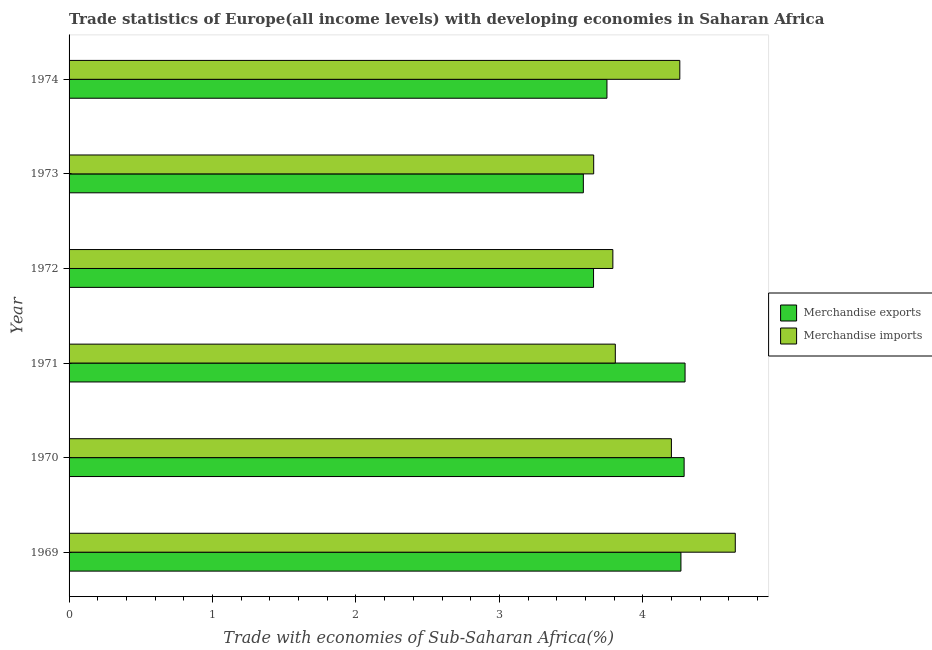Are the number of bars per tick equal to the number of legend labels?
Your answer should be very brief. Yes. How many bars are there on the 3rd tick from the top?
Provide a short and direct response. 2. What is the label of the 1st group of bars from the top?
Offer a terse response. 1974. What is the merchandise exports in 1970?
Your answer should be very brief. 4.29. Across all years, what is the maximum merchandise imports?
Keep it short and to the point. 4.64. Across all years, what is the minimum merchandise exports?
Keep it short and to the point. 3.58. In which year was the merchandise exports minimum?
Offer a very short reply. 1973. What is the total merchandise imports in the graph?
Your answer should be very brief. 24.36. What is the difference between the merchandise exports in 1969 and that in 1972?
Your answer should be very brief. 0.61. What is the difference between the merchandise imports in 1972 and the merchandise exports in 1970?
Make the answer very short. -0.5. What is the average merchandise imports per year?
Your response must be concise. 4.06. In the year 1970, what is the difference between the merchandise exports and merchandise imports?
Give a very brief answer. 0.09. In how many years, is the merchandise exports greater than 1.2 %?
Provide a succinct answer. 6. What is the ratio of the merchandise imports in 1970 to that in 1972?
Your answer should be very brief. 1.11. Is the difference between the merchandise exports in 1970 and 1972 greater than the difference between the merchandise imports in 1970 and 1972?
Offer a very short reply. Yes. What is the difference between the highest and the second highest merchandise imports?
Offer a very short reply. 0.39. What is the difference between the highest and the lowest merchandise imports?
Provide a short and direct response. 0.99. Is the sum of the merchandise exports in 1970 and 1972 greater than the maximum merchandise imports across all years?
Make the answer very short. Yes. What does the 2nd bar from the top in 1972 represents?
Keep it short and to the point. Merchandise exports. How many years are there in the graph?
Offer a very short reply. 6. What is the difference between two consecutive major ticks on the X-axis?
Offer a very short reply. 1. Are the values on the major ticks of X-axis written in scientific E-notation?
Provide a short and direct response. No. Does the graph contain any zero values?
Give a very brief answer. No. Does the graph contain grids?
Your answer should be compact. No. How many legend labels are there?
Provide a short and direct response. 2. How are the legend labels stacked?
Provide a short and direct response. Vertical. What is the title of the graph?
Your answer should be compact. Trade statistics of Europe(all income levels) with developing economies in Saharan Africa. Does "Transport services" appear as one of the legend labels in the graph?
Your answer should be compact. No. What is the label or title of the X-axis?
Offer a terse response. Trade with economies of Sub-Saharan Africa(%). What is the Trade with economies of Sub-Saharan Africa(%) of Merchandise exports in 1969?
Ensure brevity in your answer.  4.27. What is the Trade with economies of Sub-Saharan Africa(%) of Merchandise imports in 1969?
Provide a succinct answer. 4.64. What is the Trade with economies of Sub-Saharan Africa(%) in Merchandise exports in 1970?
Keep it short and to the point. 4.29. What is the Trade with economies of Sub-Saharan Africa(%) of Merchandise imports in 1970?
Your answer should be compact. 4.2. What is the Trade with economies of Sub-Saharan Africa(%) in Merchandise exports in 1971?
Make the answer very short. 4.29. What is the Trade with economies of Sub-Saharan Africa(%) of Merchandise imports in 1971?
Offer a very short reply. 3.81. What is the Trade with economies of Sub-Saharan Africa(%) in Merchandise exports in 1972?
Give a very brief answer. 3.66. What is the Trade with economies of Sub-Saharan Africa(%) in Merchandise imports in 1972?
Keep it short and to the point. 3.79. What is the Trade with economies of Sub-Saharan Africa(%) of Merchandise exports in 1973?
Keep it short and to the point. 3.58. What is the Trade with economies of Sub-Saharan Africa(%) in Merchandise imports in 1973?
Offer a terse response. 3.66. What is the Trade with economies of Sub-Saharan Africa(%) in Merchandise exports in 1974?
Give a very brief answer. 3.75. What is the Trade with economies of Sub-Saharan Africa(%) of Merchandise imports in 1974?
Offer a terse response. 4.26. Across all years, what is the maximum Trade with economies of Sub-Saharan Africa(%) in Merchandise exports?
Offer a terse response. 4.29. Across all years, what is the maximum Trade with economies of Sub-Saharan Africa(%) in Merchandise imports?
Your response must be concise. 4.64. Across all years, what is the minimum Trade with economies of Sub-Saharan Africa(%) in Merchandise exports?
Provide a short and direct response. 3.58. Across all years, what is the minimum Trade with economies of Sub-Saharan Africa(%) in Merchandise imports?
Your response must be concise. 3.66. What is the total Trade with economies of Sub-Saharan Africa(%) in Merchandise exports in the graph?
Keep it short and to the point. 23.84. What is the total Trade with economies of Sub-Saharan Africa(%) of Merchandise imports in the graph?
Offer a terse response. 24.36. What is the difference between the Trade with economies of Sub-Saharan Africa(%) of Merchandise exports in 1969 and that in 1970?
Keep it short and to the point. -0.02. What is the difference between the Trade with economies of Sub-Saharan Africa(%) in Merchandise imports in 1969 and that in 1970?
Offer a very short reply. 0.45. What is the difference between the Trade with economies of Sub-Saharan Africa(%) in Merchandise exports in 1969 and that in 1971?
Give a very brief answer. -0.03. What is the difference between the Trade with economies of Sub-Saharan Africa(%) of Merchandise imports in 1969 and that in 1971?
Offer a terse response. 0.84. What is the difference between the Trade with economies of Sub-Saharan Africa(%) of Merchandise exports in 1969 and that in 1972?
Make the answer very short. 0.61. What is the difference between the Trade with economies of Sub-Saharan Africa(%) in Merchandise imports in 1969 and that in 1972?
Offer a very short reply. 0.85. What is the difference between the Trade with economies of Sub-Saharan Africa(%) in Merchandise exports in 1969 and that in 1973?
Keep it short and to the point. 0.68. What is the difference between the Trade with economies of Sub-Saharan Africa(%) of Merchandise imports in 1969 and that in 1973?
Your response must be concise. 0.99. What is the difference between the Trade with economies of Sub-Saharan Africa(%) of Merchandise exports in 1969 and that in 1974?
Your answer should be compact. 0.52. What is the difference between the Trade with economies of Sub-Saharan Africa(%) in Merchandise imports in 1969 and that in 1974?
Your answer should be compact. 0.39. What is the difference between the Trade with economies of Sub-Saharan Africa(%) of Merchandise exports in 1970 and that in 1971?
Offer a very short reply. -0.01. What is the difference between the Trade with economies of Sub-Saharan Africa(%) in Merchandise imports in 1970 and that in 1971?
Your response must be concise. 0.39. What is the difference between the Trade with economies of Sub-Saharan Africa(%) of Merchandise exports in 1970 and that in 1972?
Make the answer very short. 0.63. What is the difference between the Trade with economies of Sub-Saharan Africa(%) of Merchandise imports in 1970 and that in 1972?
Provide a short and direct response. 0.41. What is the difference between the Trade with economies of Sub-Saharan Africa(%) in Merchandise exports in 1970 and that in 1973?
Ensure brevity in your answer.  0.7. What is the difference between the Trade with economies of Sub-Saharan Africa(%) in Merchandise imports in 1970 and that in 1973?
Provide a short and direct response. 0.54. What is the difference between the Trade with economies of Sub-Saharan Africa(%) in Merchandise exports in 1970 and that in 1974?
Your answer should be compact. 0.54. What is the difference between the Trade with economies of Sub-Saharan Africa(%) in Merchandise imports in 1970 and that in 1974?
Make the answer very short. -0.06. What is the difference between the Trade with economies of Sub-Saharan Africa(%) in Merchandise exports in 1971 and that in 1972?
Provide a short and direct response. 0.64. What is the difference between the Trade with economies of Sub-Saharan Africa(%) of Merchandise imports in 1971 and that in 1972?
Keep it short and to the point. 0.02. What is the difference between the Trade with economies of Sub-Saharan Africa(%) of Merchandise exports in 1971 and that in 1973?
Your response must be concise. 0.71. What is the difference between the Trade with economies of Sub-Saharan Africa(%) in Merchandise imports in 1971 and that in 1973?
Your response must be concise. 0.15. What is the difference between the Trade with economies of Sub-Saharan Africa(%) of Merchandise exports in 1971 and that in 1974?
Make the answer very short. 0.54. What is the difference between the Trade with economies of Sub-Saharan Africa(%) of Merchandise imports in 1971 and that in 1974?
Your answer should be very brief. -0.45. What is the difference between the Trade with economies of Sub-Saharan Africa(%) of Merchandise exports in 1972 and that in 1973?
Your response must be concise. 0.07. What is the difference between the Trade with economies of Sub-Saharan Africa(%) of Merchandise imports in 1972 and that in 1973?
Your answer should be very brief. 0.13. What is the difference between the Trade with economies of Sub-Saharan Africa(%) of Merchandise exports in 1972 and that in 1974?
Keep it short and to the point. -0.09. What is the difference between the Trade with economies of Sub-Saharan Africa(%) of Merchandise imports in 1972 and that in 1974?
Make the answer very short. -0.47. What is the difference between the Trade with economies of Sub-Saharan Africa(%) of Merchandise exports in 1973 and that in 1974?
Provide a short and direct response. -0.16. What is the difference between the Trade with economies of Sub-Saharan Africa(%) in Merchandise imports in 1973 and that in 1974?
Make the answer very short. -0.6. What is the difference between the Trade with economies of Sub-Saharan Africa(%) of Merchandise exports in 1969 and the Trade with economies of Sub-Saharan Africa(%) of Merchandise imports in 1970?
Give a very brief answer. 0.07. What is the difference between the Trade with economies of Sub-Saharan Africa(%) in Merchandise exports in 1969 and the Trade with economies of Sub-Saharan Africa(%) in Merchandise imports in 1971?
Make the answer very short. 0.46. What is the difference between the Trade with economies of Sub-Saharan Africa(%) of Merchandise exports in 1969 and the Trade with economies of Sub-Saharan Africa(%) of Merchandise imports in 1972?
Your answer should be compact. 0.47. What is the difference between the Trade with economies of Sub-Saharan Africa(%) of Merchandise exports in 1969 and the Trade with economies of Sub-Saharan Africa(%) of Merchandise imports in 1973?
Offer a terse response. 0.61. What is the difference between the Trade with economies of Sub-Saharan Africa(%) in Merchandise exports in 1969 and the Trade with economies of Sub-Saharan Africa(%) in Merchandise imports in 1974?
Give a very brief answer. 0.01. What is the difference between the Trade with economies of Sub-Saharan Africa(%) in Merchandise exports in 1970 and the Trade with economies of Sub-Saharan Africa(%) in Merchandise imports in 1971?
Provide a succinct answer. 0.48. What is the difference between the Trade with economies of Sub-Saharan Africa(%) of Merchandise exports in 1970 and the Trade with economies of Sub-Saharan Africa(%) of Merchandise imports in 1972?
Ensure brevity in your answer.  0.5. What is the difference between the Trade with economies of Sub-Saharan Africa(%) in Merchandise exports in 1970 and the Trade with economies of Sub-Saharan Africa(%) in Merchandise imports in 1973?
Your response must be concise. 0.63. What is the difference between the Trade with economies of Sub-Saharan Africa(%) in Merchandise exports in 1970 and the Trade with economies of Sub-Saharan Africa(%) in Merchandise imports in 1974?
Your answer should be compact. 0.03. What is the difference between the Trade with economies of Sub-Saharan Africa(%) of Merchandise exports in 1971 and the Trade with economies of Sub-Saharan Africa(%) of Merchandise imports in 1972?
Provide a short and direct response. 0.5. What is the difference between the Trade with economies of Sub-Saharan Africa(%) in Merchandise exports in 1971 and the Trade with economies of Sub-Saharan Africa(%) in Merchandise imports in 1973?
Your response must be concise. 0.64. What is the difference between the Trade with economies of Sub-Saharan Africa(%) in Merchandise exports in 1971 and the Trade with economies of Sub-Saharan Africa(%) in Merchandise imports in 1974?
Provide a succinct answer. 0.04. What is the difference between the Trade with economies of Sub-Saharan Africa(%) of Merchandise exports in 1972 and the Trade with economies of Sub-Saharan Africa(%) of Merchandise imports in 1973?
Give a very brief answer. -0. What is the difference between the Trade with economies of Sub-Saharan Africa(%) in Merchandise exports in 1972 and the Trade with economies of Sub-Saharan Africa(%) in Merchandise imports in 1974?
Your response must be concise. -0.6. What is the difference between the Trade with economies of Sub-Saharan Africa(%) in Merchandise exports in 1973 and the Trade with economies of Sub-Saharan Africa(%) in Merchandise imports in 1974?
Ensure brevity in your answer.  -0.67. What is the average Trade with economies of Sub-Saharan Africa(%) of Merchandise exports per year?
Keep it short and to the point. 3.97. What is the average Trade with economies of Sub-Saharan Africa(%) in Merchandise imports per year?
Give a very brief answer. 4.06. In the year 1969, what is the difference between the Trade with economies of Sub-Saharan Africa(%) in Merchandise exports and Trade with economies of Sub-Saharan Africa(%) in Merchandise imports?
Make the answer very short. -0.38. In the year 1970, what is the difference between the Trade with economies of Sub-Saharan Africa(%) in Merchandise exports and Trade with economies of Sub-Saharan Africa(%) in Merchandise imports?
Ensure brevity in your answer.  0.09. In the year 1971, what is the difference between the Trade with economies of Sub-Saharan Africa(%) in Merchandise exports and Trade with economies of Sub-Saharan Africa(%) in Merchandise imports?
Offer a terse response. 0.49. In the year 1972, what is the difference between the Trade with economies of Sub-Saharan Africa(%) in Merchandise exports and Trade with economies of Sub-Saharan Africa(%) in Merchandise imports?
Offer a very short reply. -0.13. In the year 1973, what is the difference between the Trade with economies of Sub-Saharan Africa(%) of Merchandise exports and Trade with economies of Sub-Saharan Africa(%) of Merchandise imports?
Make the answer very short. -0.07. In the year 1974, what is the difference between the Trade with economies of Sub-Saharan Africa(%) of Merchandise exports and Trade with economies of Sub-Saharan Africa(%) of Merchandise imports?
Offer a terse response. -0.51. What is the ratio of the Trade with economies of Sub-Saharan Africa(%) in Merchandise imports in 1969 to that in 1970?
Your answer should be very brief. 1.11. What is the ratio of the Trade with economies of Sub-Saharan Africa(%) in Merchandise imports in 1969 to that in 1971?
Your answer should be very brief. 1.22. What is the ratio of the Trade with economies of Sub-Saharan Africa(%) of Merchandise exports in 1969 to that in 1972?
Keep it short and to the point. 1.17. What is the ratio of the Trade with economies of Sub-Saharan Africa(%) of Merchandise imports in 1969 to that in 1972?
Provide a succinct answer. 1.23. What is the ratio of the Trade with economies of Sub-Saharan Africa(%) of Merchandise exports in 1969 to that in 1973?
Make the answer very short. 1.19. What is the ratio of the Trade with economies of Sub-Saharan Africa(%) of Merchandise imports in 1969 to that in 1973?
Your response must be concise. 1.27. What is the ratio of the Trade with economies of Sub-Saharan Africa(%) of Merchandise exports in 1969 to that in 1974?
Your answer should be compact. 1.14. What is the ratio of the Trade with economies of Sub-Saharan Africa(%) of Merchandise imports in 1969 to that in 1974?
Provide a short and direct response. 1.09. What is the ratio of the Trade with economies of Sub-Saharan Africa(%) of Merchandise imports in 1970 to that in 1971?
Provide a succinct answer. 1.1. What is the ratio of the Trade with economies of Sub-Saharan Africa(%) in Merchandise exports in 1970 to that in 1972?
Keep it short and to the point. 1.17. What is the ratio of the Trade with economies of Sub-Saharan Africa(%) of Merchandise imports in 1970 to that in 1972?
Keep it short and to the point. 1.11. What is the ratio of the Trade with economies of Sub-Saharan Africa(%) in Merchandise exports in 1970 to that in 1973?
Your answer should be very brief. 1.2. What is the ratio of the Trade with economies of Sub-Saharan Africa(%) of Merchandise imports in 1970 to that in 1973?
Ensure brevity in your answer.  1.15. What is the ratio of the Trade with economies of Sub-Saharan Africa(%) of Merchandise exports in 1970 to that in 1974?
Your answer should be very brief. 1.14. What is the ratio of the Trade with economies of Sub-Saharan Africa(%) in Merchandise imports in 1970 to that in 1974?
Offer a very short reply. 0.99. What is the ratio of the Trade with economies of Sub-Saharan Africa(%) in Merchandise exports in 1971 to that in 1972?
Offer a terse response. 1.17. What is the ratio of the Trade with economies of Sub-Saharan Africa(%) in Merchandise exports in 1971 to that in 1973?
Offer a very short reply. 1.2. What is the ratio of the Trade with economies of Sub-Saharan Africa(%) in Merchandise imports in 1971 to that in 1973?
Your answer should be compact. 1.04. What is the ratio of the Trade with economies of Sub-Saharan Africa(%) of Merchandise exports in 1971 to that in 1974?
Keep it short and to the point. 1.15. What is the ratio of the Trade with economies of Sub-Saharan Africa(%) in Merchandise imports in 1971 to that in 1974?
Your response must be concise. 0.89. What is the ratio of the Trade with economies of Sub-Saharan Africa(%) of Merchandise exports in 1972 to that in 1973?
Provide a succinct answer. 1.02. What is the ratio of the Trade with economies of Sub-Saharan Africa(%) of Merchandise imports in 1972 to that in 1973?
Your response must be concise. 1.04. What is the ratio of the Trade with economies of Sub-Saharan Africa(%) of Merchandise exports in 1972 to that in 1974?
Give a very brief answer. 0.98. What is the ratio of the Trade with economies of Sub-Saharan Africa(%) in Merchandise imports in 1972 to that in 1974?
Keep it short and to the point. 0.89. What is the ratio of the Trade with economies of Sub-Saharan Africa(%) of Merchandise exports in 1973 to that in 1974?
Offer a terse response. 0.96. What is the ratio of the Trade with economies of Sub-Saharan Africa(%) in Merchandise imports in 1973 to that in 1974?
Your answer should be very brief. 0.86. What is the difference between the highest and the second highest Trade with economies of Sub-Saharan Africa(%) in Merchandise exports?
Give a very brief answer. 0.01. What is the difference between the highest and the second highest Trade with economies of Sub-Saharan Africa(%) in Merchandise imports?
Your response must be concise. 0.39. What is the difference between the highest and the lowest Trade with economies of Sub-Saharan Africa(%) of Merchandise exports?
Offer a terse response. 0.71. 